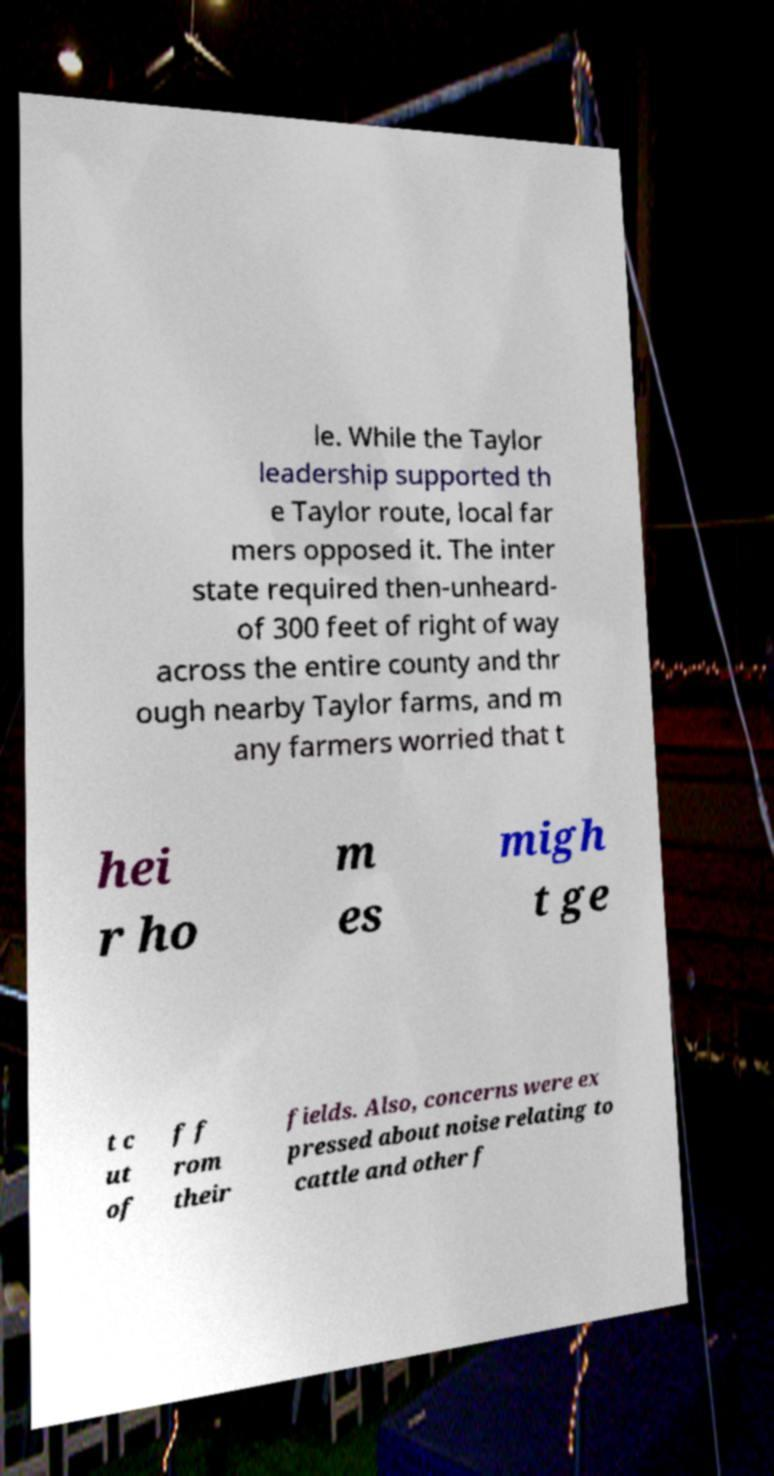For documentation purposes, I need the text within this image transcribed. Could you provide that? le. While the Taylor leadership supported th e Taylor route, local far mers opposed it. The inter state required then-unheard- of 300 feet of right of way across the entire county and thr ough nearby Taylor farms, and m any farmers worried that t hei r ho m es migh t ge t c ut of f f rom their fields. Also, concerns were ex pressed about noise relating to cattle and other f 